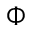<formula> <loc_0><loc_0><loc_500><loc_500>\Phi</formula> 